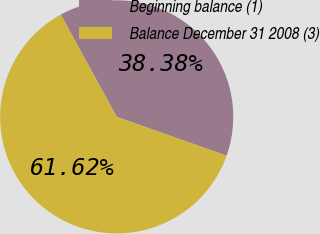Convert chart to OTSL. <chart><loc_0><loc_0><loc_500><loc_500><pie_chart><fcel>Beginning balance (1)<fcel>Balance December 31 2008 (3)<nl><fcel>38.38%<fcel>61.62%<nl></chart> 